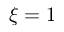<formula> <loc_0><loc_0><loc_500><loc_500>\xi = 1</formula> 